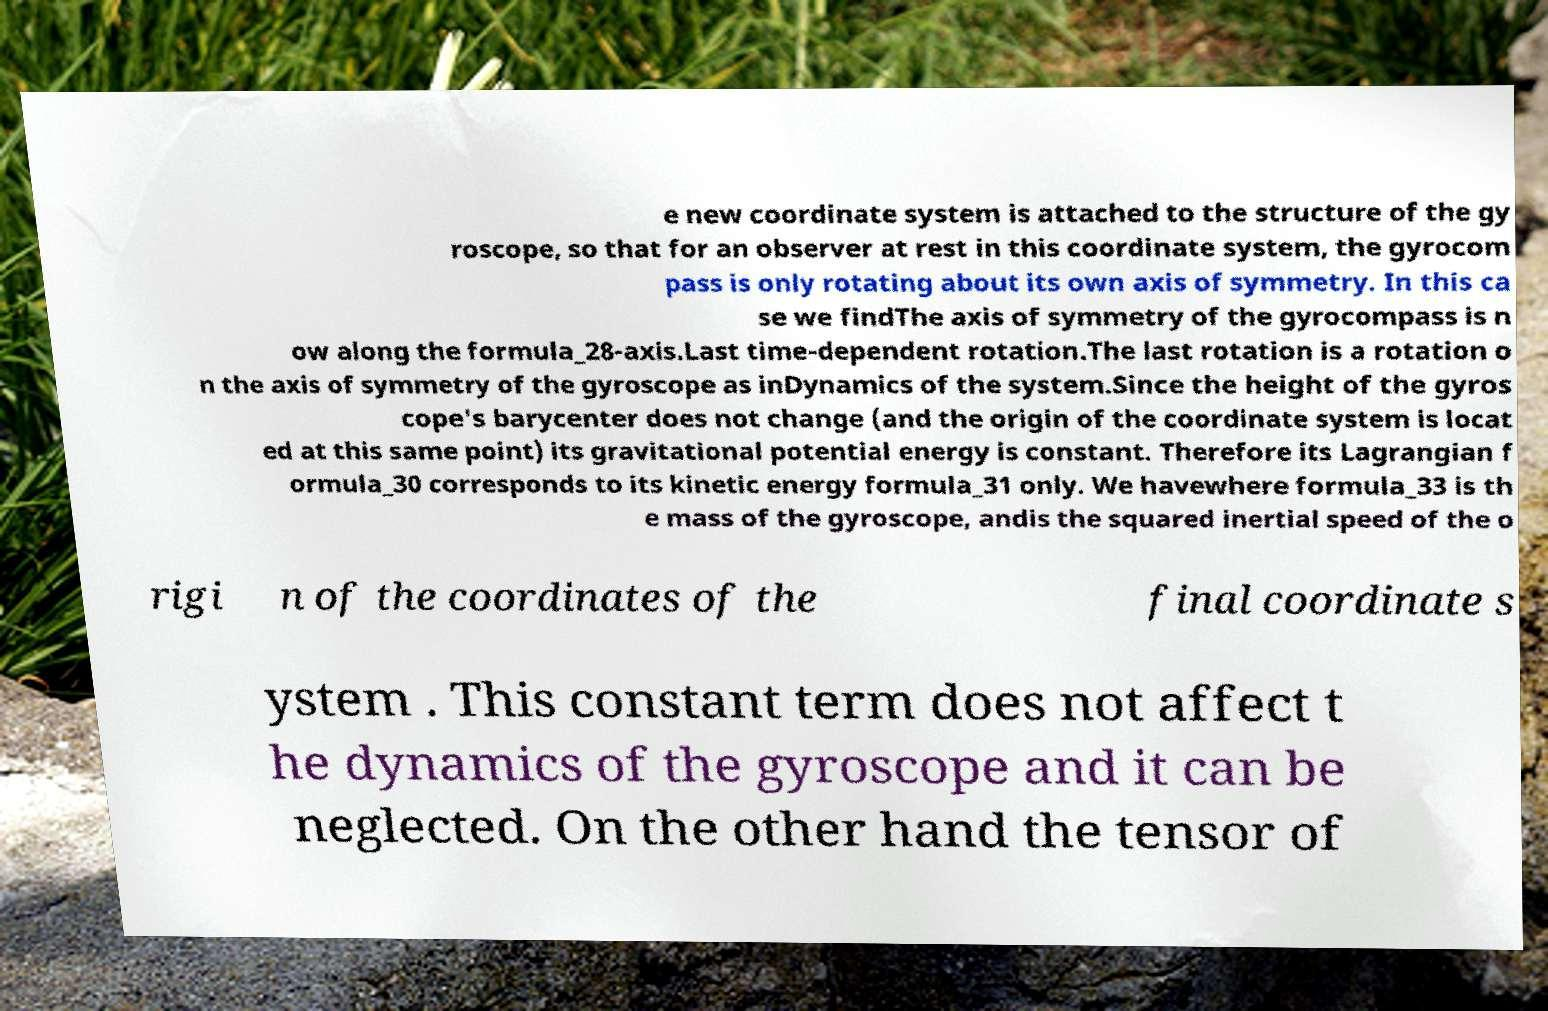Can you accurately transcribe the text from the provided image for me? e new coordinate system is attached to the structure of the gy roscope, so that for an observer at rest in this coordinate system, the gyrocom pass is only rotating about its own axis of symmetry. In this ca se we findThe axis of symmetry of the gyrocompass is n ow along the formula_28-axis.Last time-dependent rotation.The last rotation is a rotation o n the axis of symmetry of the gyroscope as inDynamics of the system.Since the height of the gyros cope's barycenter does not change (and the origin of the coordinate system is locat ed at this same point) its gravitational potential energy is constant. Therefore its Lagrangian f ormula_30 corresponds to its kinetic energy formula_31 only. We havewhere formula_33 is th e mass of the gyroscope, andis the squared inertial speed of the o rigi n of the coordinates of the final coordinate s ystem . This constant term does not affect t he dynamics of the gyroscope and it can be neglected. On the other hand the tensor of 